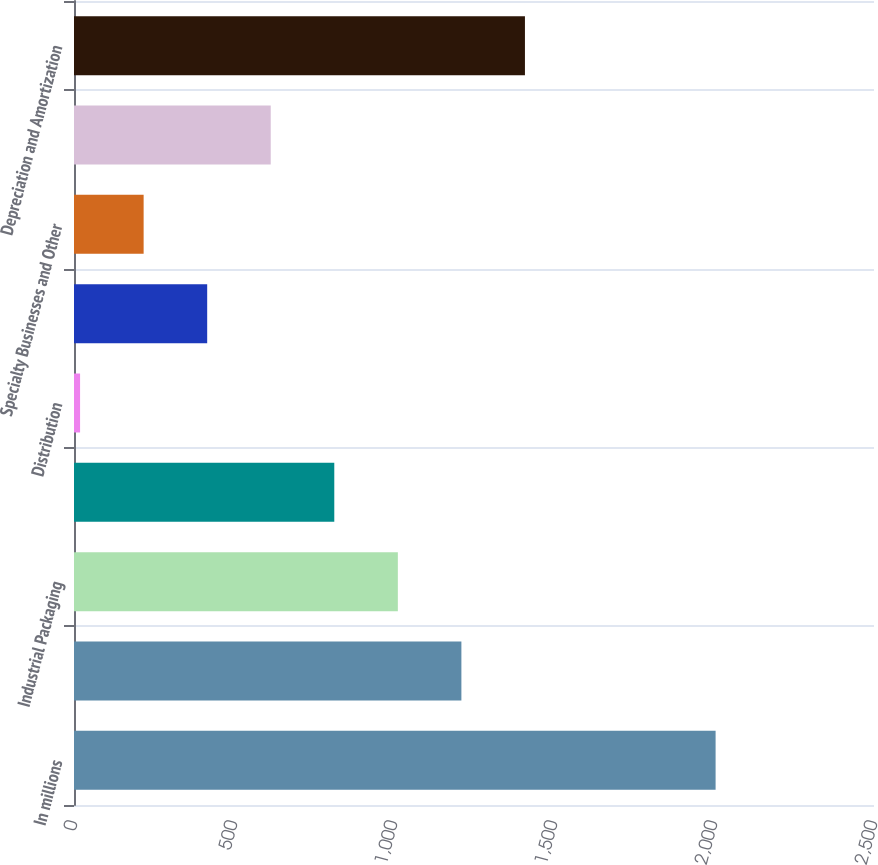<chart> <loc_0><loc_0><loc_500><loc_500><bar_chart><fcel>In millions<fcel>Printing Papers<fcel>Industrial Packaging<fcel>Consumer Packaging<fcel>Distribution<fcel>Forest Products (g)<fcel>Specialty Businesses and Other<fcel>Corporate<fcel>Depreciation and Amortization<nl><fcel>2005<fcel>1210.6<fcel>1012<fcel>813.4<fcel>19<fcel>416.2<fcel>217.6<fcel>614.8<fcel>1409.2<nl></chart> 